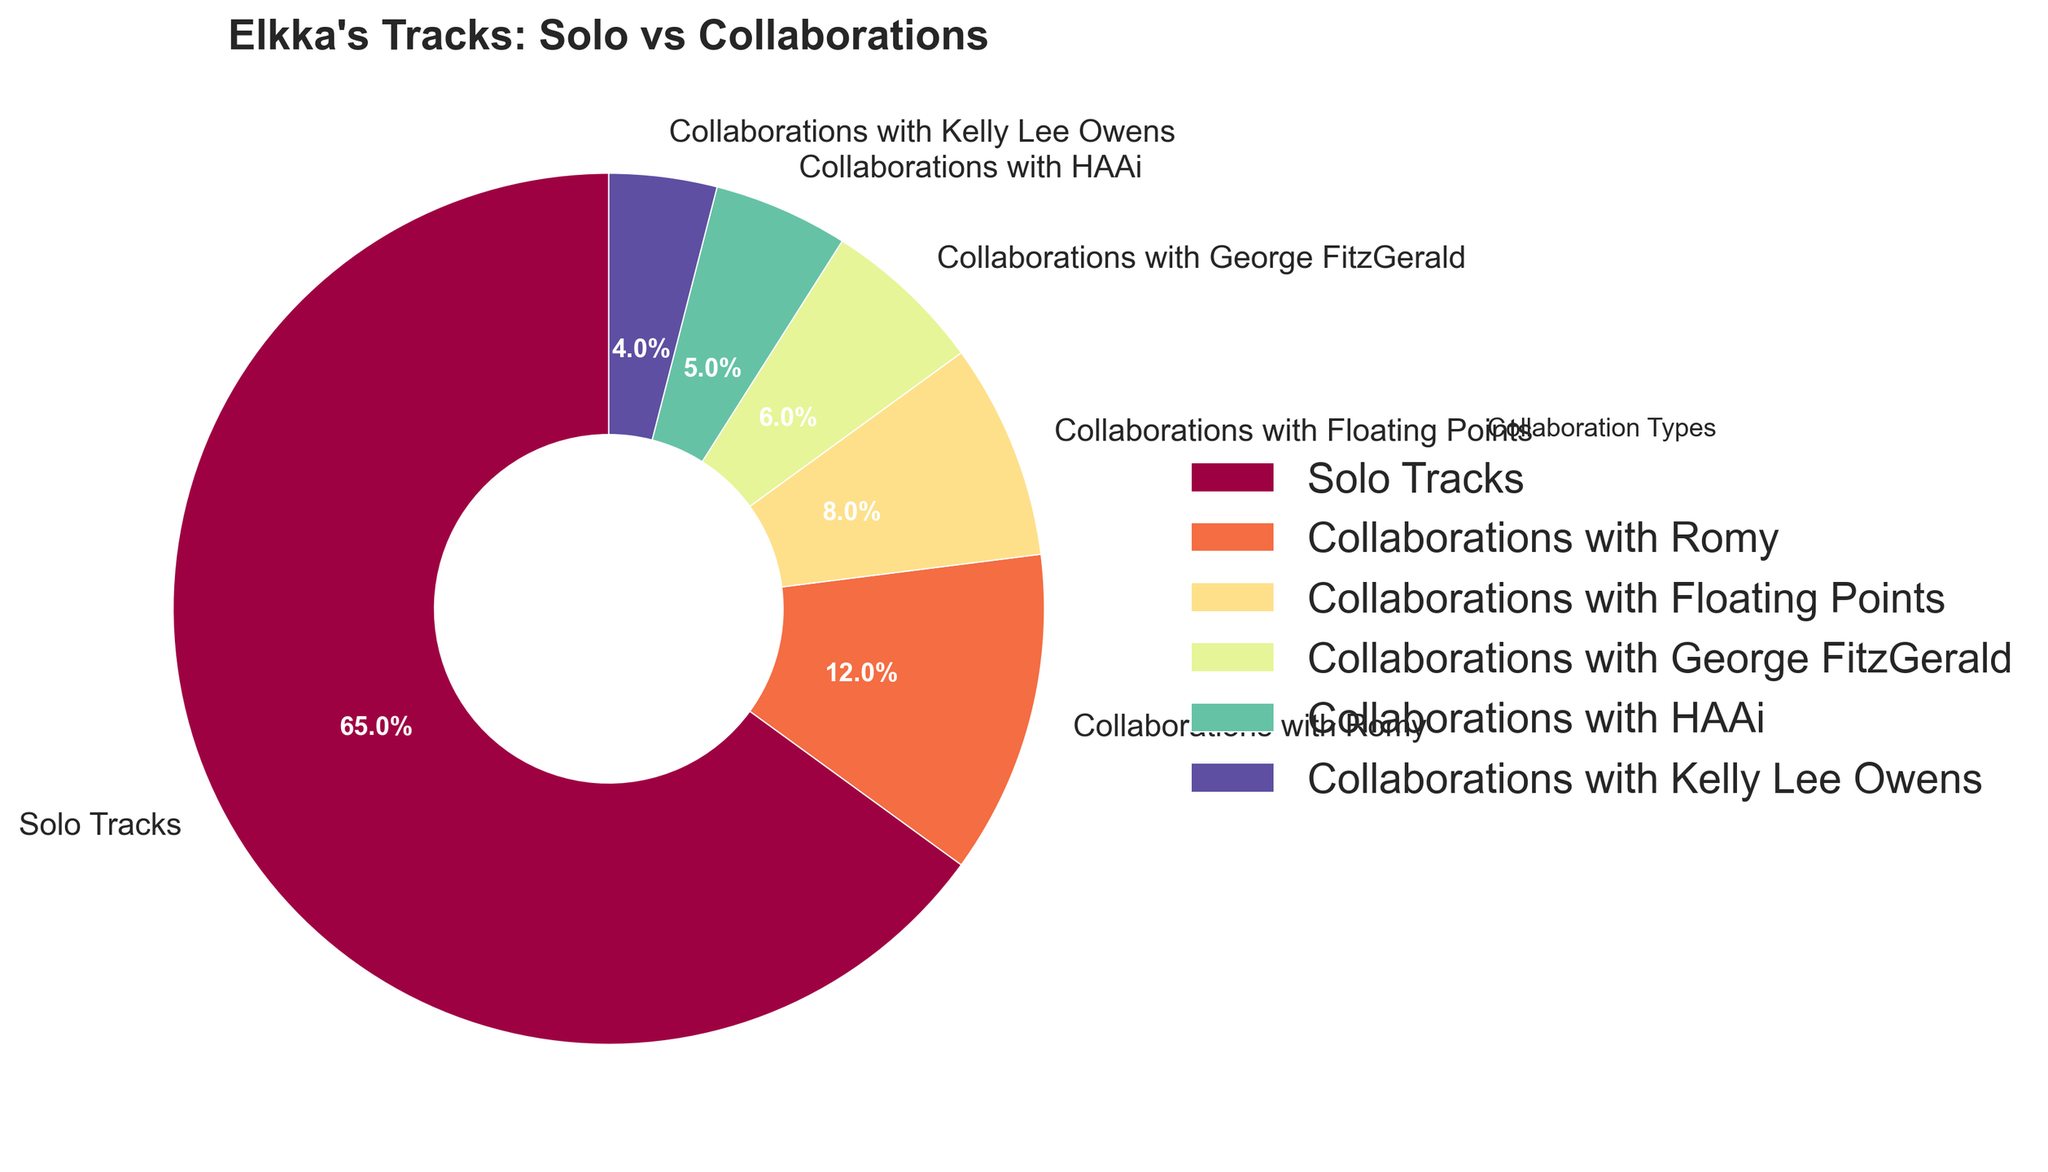What's the percentage of Elkka's solo tracks? The chart shows different segments for various types of tracks. The label for solo tracks indicates it is 65%.
Answer: 65% Which artist has the highest percentage of collaborations with Elkka? By observing the chart, the segment corresponding to the highest percentage (after solo tracks) is labeled "Collaborations with Romy" at 12%.
Answer: Romy What's the combined percentage of collaborations with Romy and Floating Points? Add the percentages for Romy (12%) and Floating Points (8%): 12 + 8 = 20
Answer: 20% How does the percentage of collaborations with George FitzGerald compare to those with HAAi? The chart shows the percentage for George FitzGerald is 6%, while for HAAi it is 5%. Comparatively, 6% is greater than 5%.
Answer: George FitzGerald has more Which collaboration type occupies the smallest segment of the pie chart? The chart shows the smallest segment labeled "Collaborations with Kelly Lee Owens" with a percentage of 4%.
Answer: Kelly Lee Owens What's the sum of the percentages of collaborations with Romy, Floating Points, and George FitzGerald? Sum the percentages for Romy (12%), Floating Points (8%), and George FitzGerald (6%): 12 + 8 + 6 = 26
Answer: 26% How much larger is the percentage of solo tracks compared to the sum of collaborations with HAAi and Kelly Lee Owens? Calculate the sum of percentages for HAAi (5%) and Kelly Lee Owens (4%): 5 + 4 = 9. Then, find the difference between solo tracks (65%) and this sum: 65 - 9 = 56.
Answer: 56% Which collaborations have a higher percentage than those with Kelly Lee Owens? Comparing the labels, collaborations with Romy (12%), Floating Points (8%), George FitzGerald (6%), and HAAi (5%) are all higher than Kelly Lee Owens (4%).
Answer: Romy, Floating Points, George FitzGerald, and HAAi 